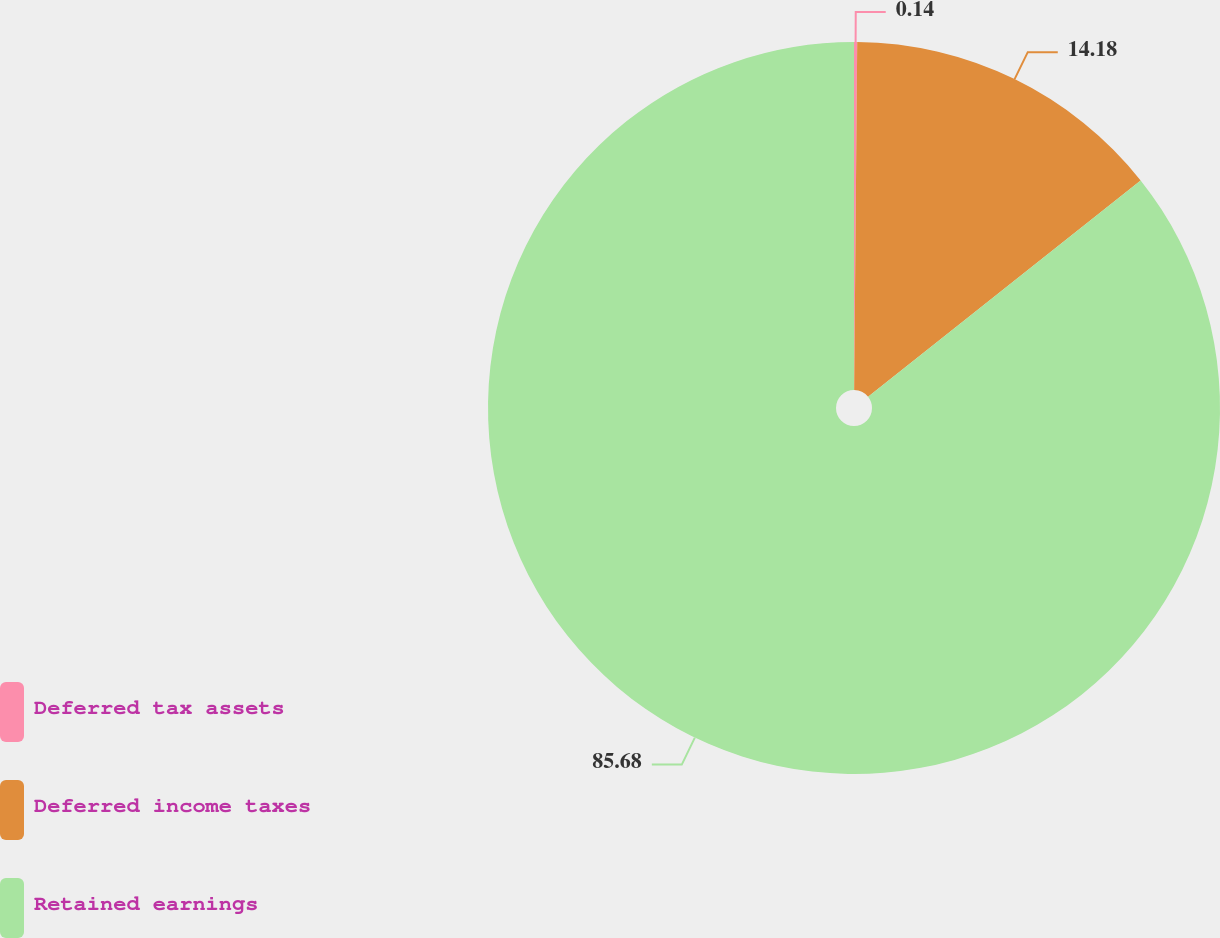Convert chart. <chart><loc_0><loc_0><loc_500><loc_500><pie_chart><fcel>Deferred tax assets<fcel>Deferred income taxes<fcel>Retained earnings<nl><fcel>0.14%<fcel>14.18%<fcel>85.68%<nl></chart> 